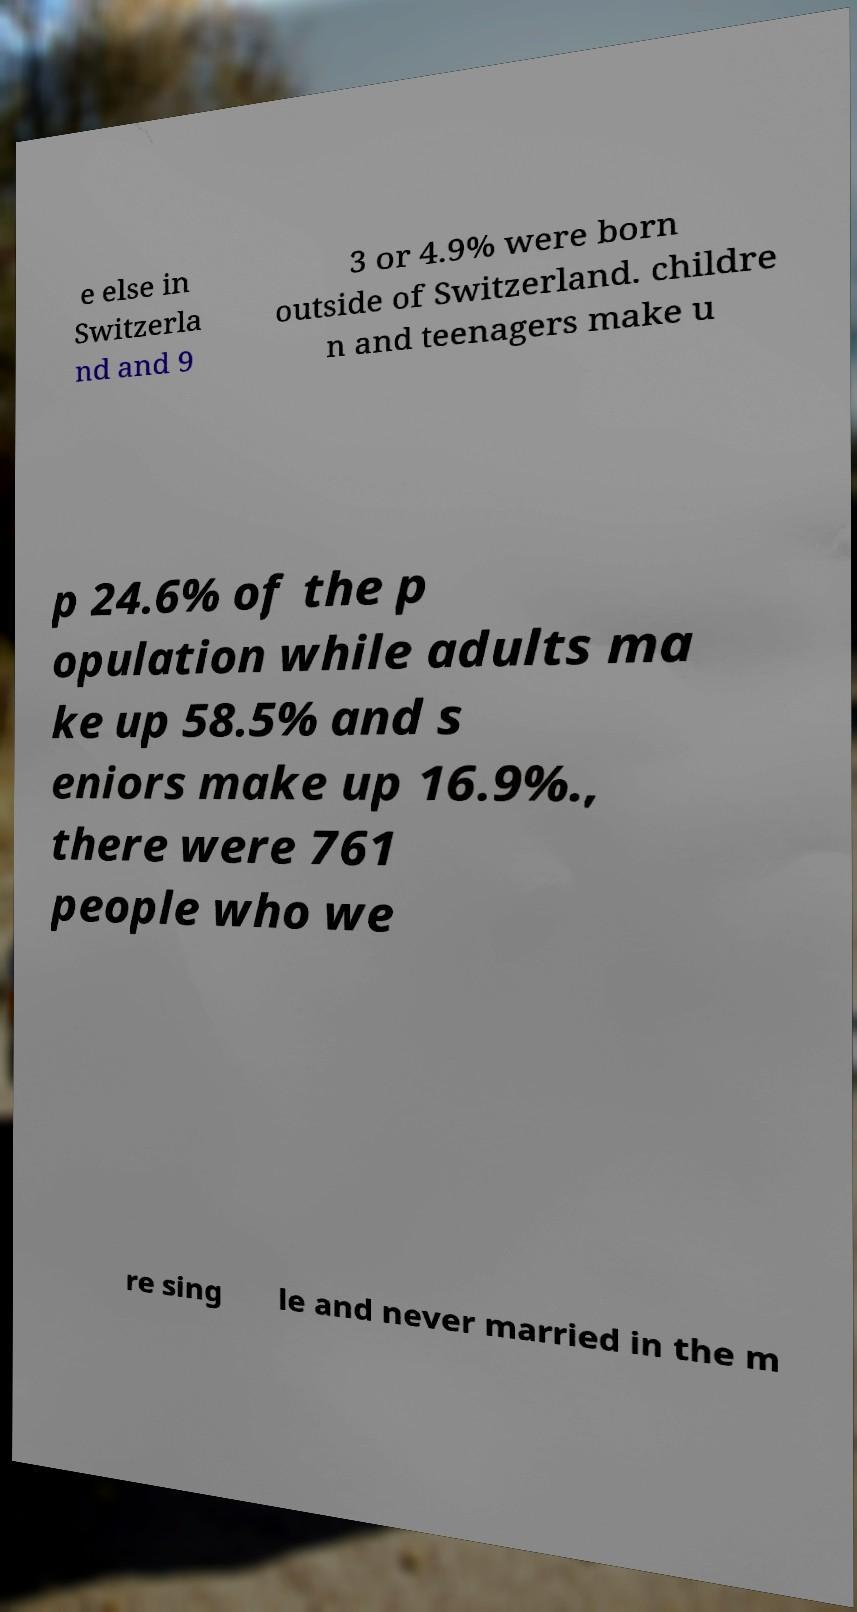For documentation purposes, I need the text within this image transcribed. Could you provide that? e else in Switzerla nd and 9 3 or 4.9% were born outside of Switzerland. childre n and teenagers make u p 24.6% of the p opulation while adults ma ke up 58.5% and s eniors make up 16.9%., there were 761 people who we re sing le and never married in the m 